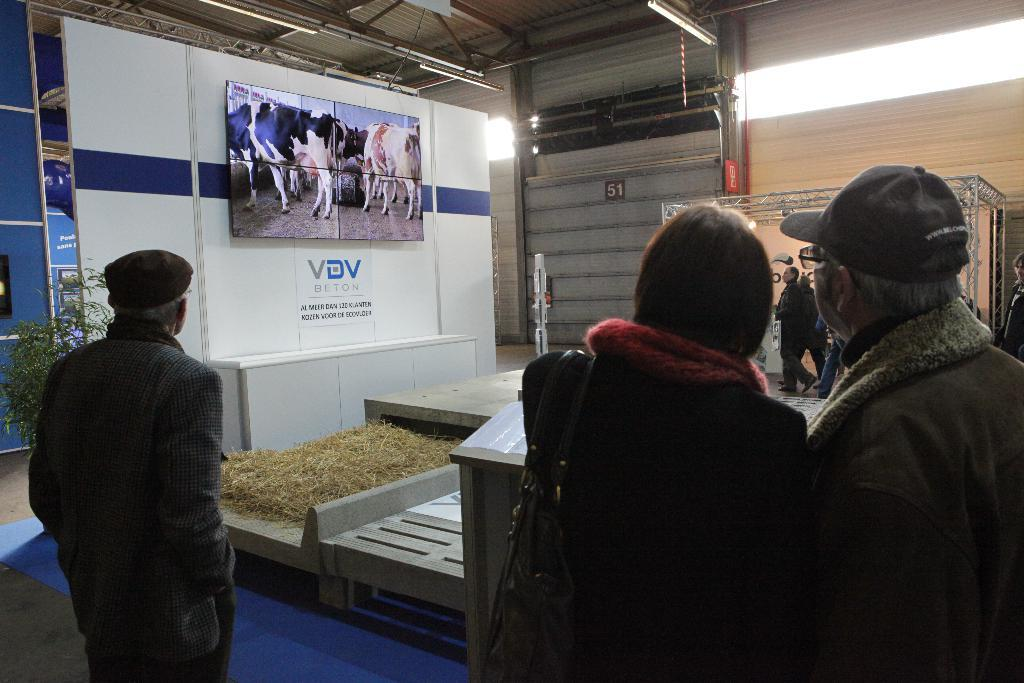How many persons are visible in the image? There are persons standing in the image. What type of natural environment is present in the image? There is grass and trees in the image. What is the board in the image used for? The board has an image of animals, which suggests it might be a sign or display. What type of structure is present in the image? There is a shed in the image. What type of lighting is present in the image? There are lights in the image. Can you see a stream running through the grass in the image? There is no stream visible in the image; it features grass, trees, a shed, and a board with an image of animals. What type of crack is present in the image? There is no crack present in the image. 